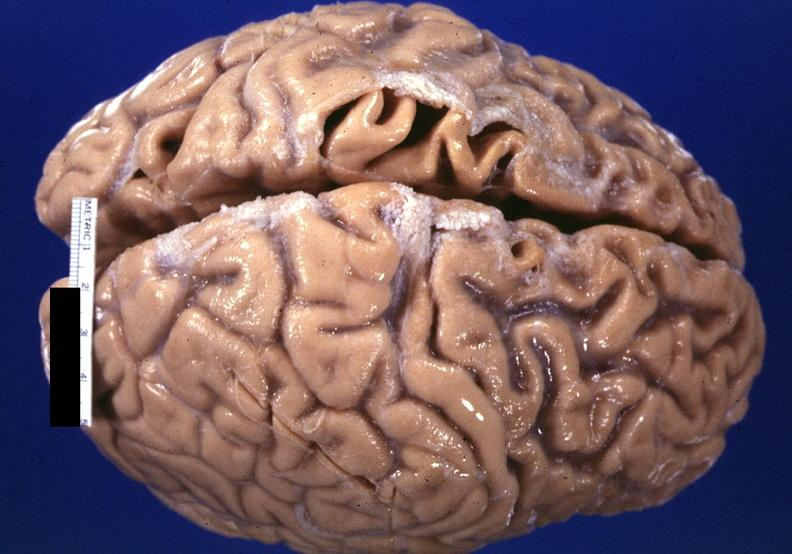what does this image show?
Answer the question using a single word or phrase. Brain 